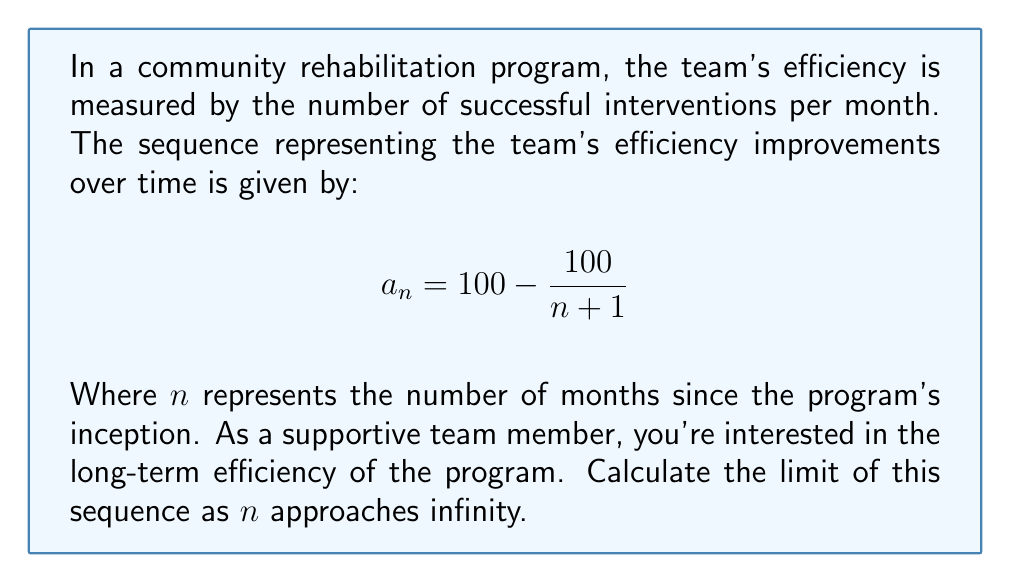Can you answer this question? To find the limit of the sequence as $n$ approaches infinity, we'll follow these steps:

1) First, let's examine the general term of the sequence:
   $$a_n = 100 - \frac{100}{n+1}$$

2) As $n$ approaches infinity, the fraction $\frac{100}{n+1}$ will approach zero. This is because the denominator grows infinitely large while the numerator remains constant.

3) We can verify this mathematically:
   $$\lim_{n \to \infty} \frac{100}{n+1} = 100 \cdot \lim_{n \to \infty} \frac{1}{n+1} = 100 \cdot 0 = 0$$

4) Now, let's consider the limit of the entire sequence:
   $$\lim_{n \to \infty} a_n = \lim_{n \to \infty} (100 - \frac{100}{n+1})$$

5) We can separate this limit:
   $$= \lim_{n \to \infty} 100 - \lim_{n \to \infty} \frac{100}{n+1}$$

6) We know that the limit of a constant is the constant itself, and we've already shown that the limit of $\frac{100}{n+1}$ is 0:
   $$= 100 - 0 = 100$$

Therefore, the limit of the sequence as $n$ approaches infinity is 100.
Answer: 100 